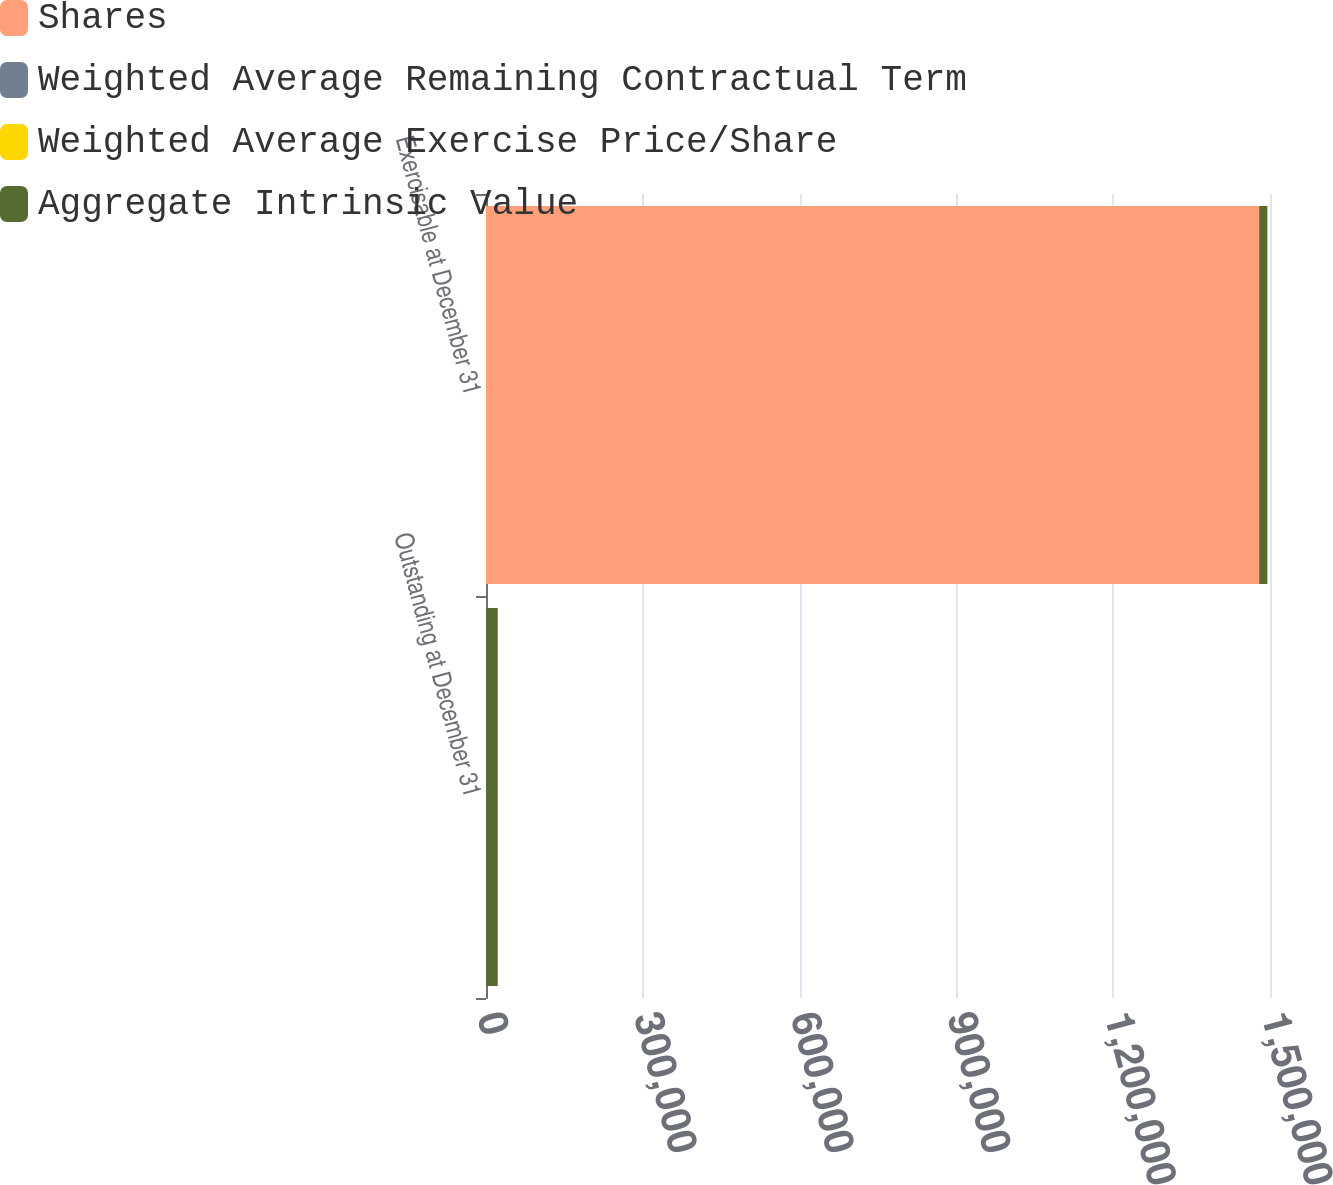Convert chart. <chart><loc_0><loc_0><loc_500><loc_500><stacked_bar_chart><ecel><fcel>Outstanding at December 31<fcel>Exercisable at December 31<nl><fcel>Shares<fcel>81.16<fcel>1.47918e+06<nl><fcel>Weighted Average Remaining Contractual Term<fcel>81.16<fcel>79.33<nl><fcel>Weighted Average Exercise Price/Share<fcel>5.8<fcel>3.9<nl><fcel>Aggregate Intrinsic Value<fcel>22309<fcel>15773<nl></chart> 